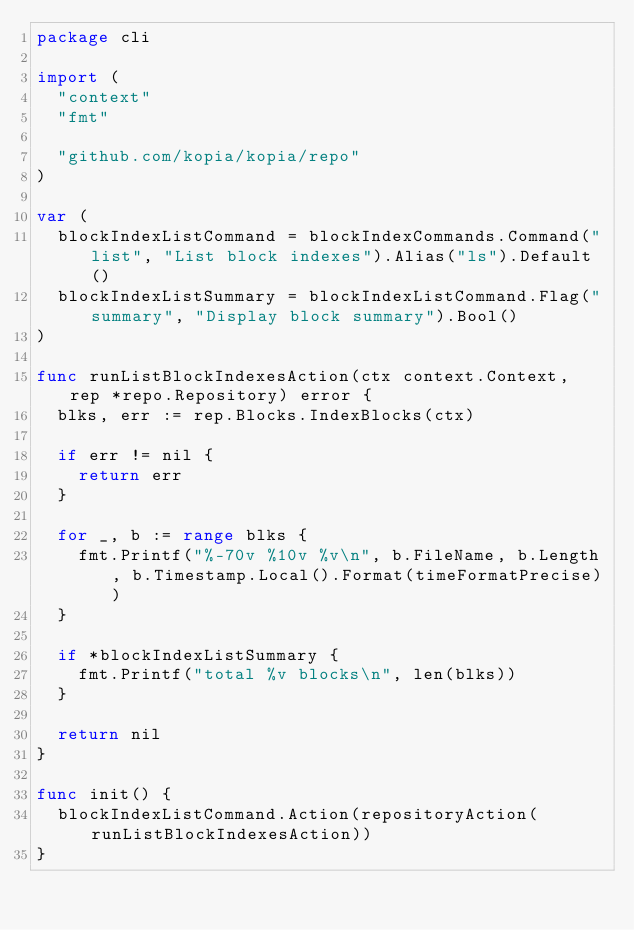<code> <loc_0><loc_0><loc_500><loc_500><_Go_>package cli

import (
	"context"
	"fmt"

	"github.com/kopia/kopia/repo"
)

var (
	blockIndexListCommand = blockIndexCommands.Command("list", "List block indexes").Alias("ls").Default()
	blockIndexListSummary = blockIndexListCommand.Flag("summary", "Display block summary").Bool()
)

func runListBlockIndexesAction(ctx context.Context, rep *repo.Repository) error {
	blks, err := rep.Blocks.IndexBlocks(ctx)

	if err != nil {
		return err
	}

	for _, b := range blks {
		fmt.Printf("%-70v %10v %v\n", b.FileName, b.Length, b.Timestamp.Local().Format(timeFormatPrecise))
	}

	if *blockIndexListSummary {
		fmt.Printf("total %v blocks\n", len(blks))
	}

	return nil
}

func init() {
	blockIndexListCommand.Action(repositoryAction(runListBlockIndexesAction))
}
</code> 